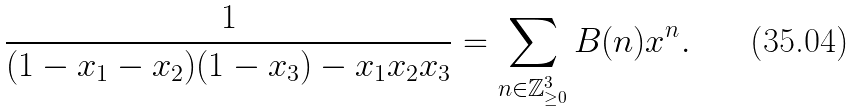Convert formula to latex. <formula><loc_0><loc_0><loc_500><loc_500>\frac { 1 } { ( 1 - x _ { 1 } - x _ { 2 } ) ( 1 - x _ { 3 } ) - x _ { 1 } x _ { 2 } x _ { 3 } } = \sum _ { n \in \mathbb { Z } _ { \geq 0 } ^ { 3 } } B ( n ) x ^ { n } .</formula> 